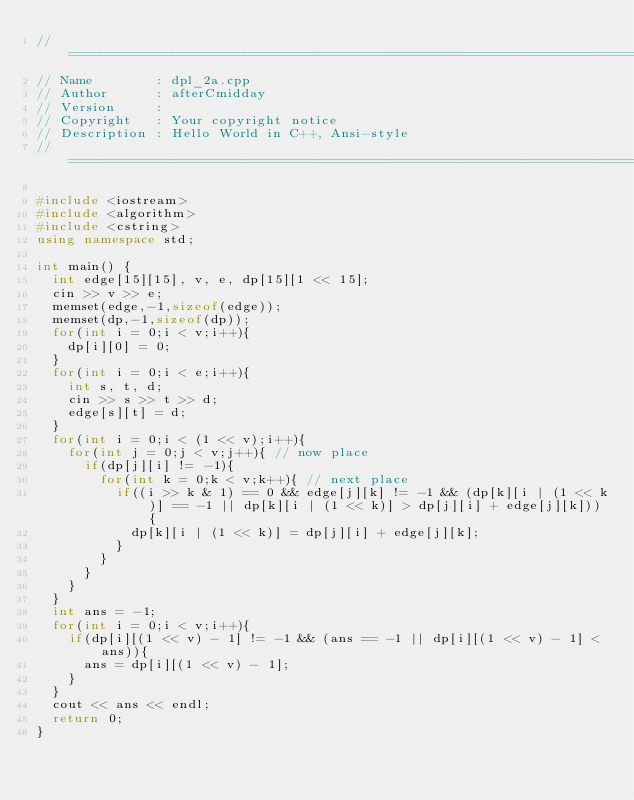Convert code to text. <code><loc_0><loc_0><loc_500><loc_500><_C++_>//============================================================================
// Name        : dpl_2a.cpp
// Author      : afterCmidday
// Version     :
// Copyright   : Your copyright notice
// Description : Hello World in C++, Ansi-style
//============================================================================

#include <iostream>
#include <algorithm>
#include <cstring>
using namespace std;

int main() {
	int edge[15][15], v, e, dp[15][1 << 15];
	cin >> v >> e;
	memset(edge,-1,sizeof(edge));
	memset(dp,-1,sizeof(dp));
	for(int i = 0;i < v;i++){
		dp[i][0] = 0;
	}
	for(int i = 0;i < e;i++){
		int s, t, d;
		cin >> s >> t >> d;
		edge[s][t] = d;
	}
	for(int i = 0;i < (1 << v);i++){
		for(int j = 0;j < v;j++){ // now place
			if(dp[j][i] != -1){
				for(int k = 0;k < v;k++){ // next place
					if((i >> k & 1) == 0 && edge[j][k] != -1 && (dp[k][i | (1 << k)] == -1 || dp[k][i | (1 << k)] > dp[j][i] + edge[j][k])){
						dp[k][i | (1 << k)] = dp[j][i] + edge[j][k];
					}
				}
			}
		}
	}
	int ans = -1;
	for(int i = 0;i < v;i++){
		if(dp[i][(1 << v) - 1] != -1 && (ans == -1 || dp[i][(1 << v) - 1] < ans)){
			ans = dp[i][(1 << v) - 1];
		}
	}
	cout << ans << endl;
	return 0;
}</code> 